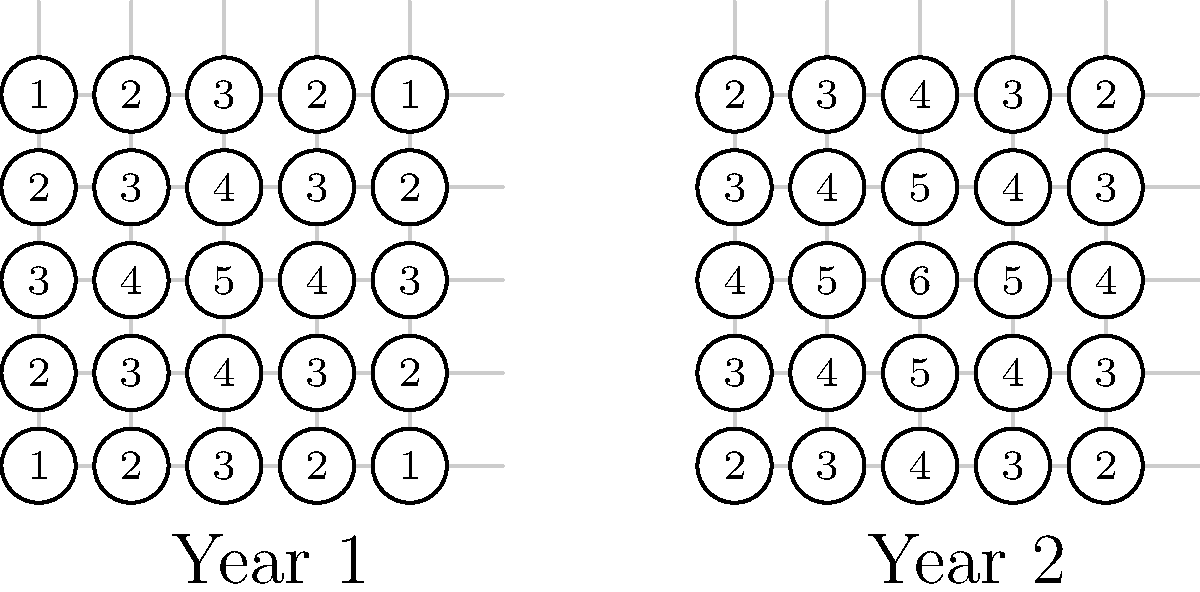Analyze the two maps representing drought severity in a region for Year 1 and Year 2. The numbers indicate drought intensity on a scale of 1-6, with higher numbers representing more severe drought conditions. How has the spatial pattern of drought changed from Year 1 to Year 2, and what method would you use to represent this change visually? To analyze the change in drought patterns and represent it visually, we should follow these steps:

1. Observe the patterns in both maps:
   - Year 1: Peak drought intensity of 5 in the center, decreasing outwards.
   - Year 2: Peak drought intensity of 6 in the center, decreasing outwards.

2. Compare the two maps:
   - Overall drought intensity has increased across the entire region.
   - The spatial pattern remains similar, with the highest intensity in the center.

3. Quantify the change:
   - Each grid cell shows an increase of 1 in drought intensity from Year 1 to Year 2.

4. Method to represent change visually:
   - Use vector isolines (contour lines) to show the spatial distribution of drought intensity.
   - For each year, draw isolines connecting points of equal drought intensity.
   - Compare the isolines between years to visualize the change in drought extent and severity.

5. Process for creating vector isolines:
   a. Identify the range of values (1-5 for Year 1, 2-6 for Year 2).
   b. Choose appropriate intervals (e.g., every 1 or 2 units).
   c. Interpolate between data points to estimate the position of each isoline.
   d. Draw smooth curves connecting points of equal value.

6. Interpretation:
   - Isolines for Year 2 would be shifted outward compared to Year 1, indicating an expansion of more severe drought conditions.
   - The spacing between isolines would remain similar, showing that the gradient of change is consistent across the region.

This method allows for a clear visual comparison of the drought's spatial extent and intensity between the two years.
Answer: Vector isolines to show expanded and intensified drought conditions 